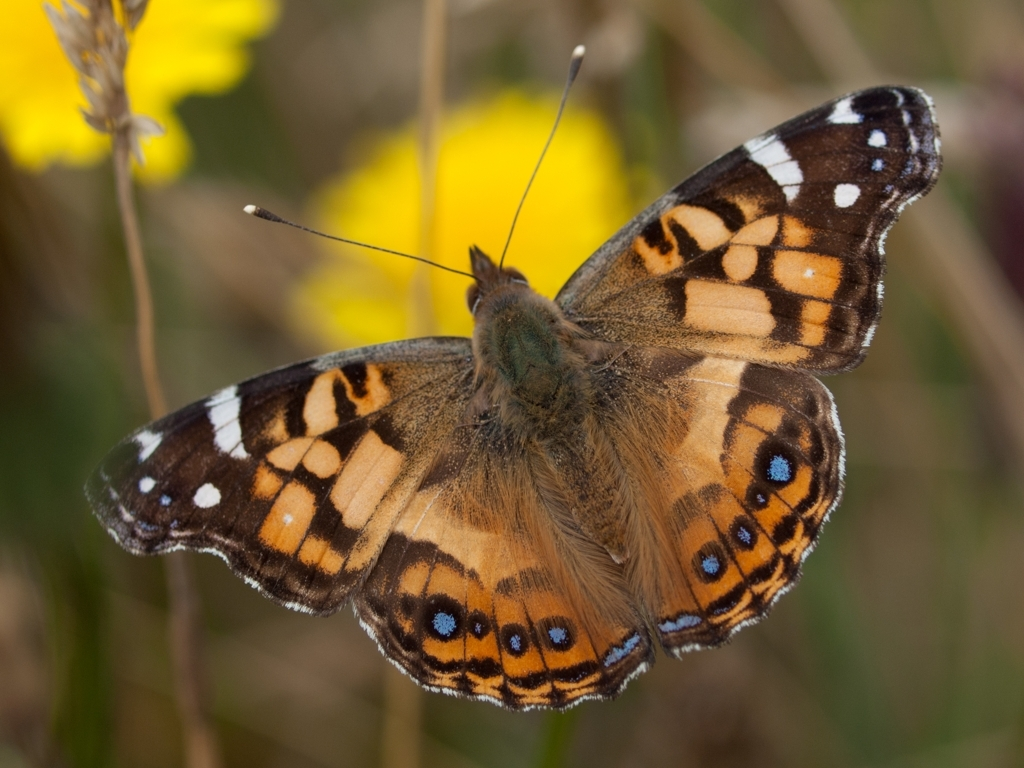How are the texture details of the captured butterfly subject? The butterfly depicted in the image showcases intricate texture details, highlighted by the fine scales on its wings which provide the appearance of a vivid mosaic. The interplay of orange, brown, white, and bits of blue near the lower edges of its hindwings creates a striking contrast against the blurry backdrop of yellow wildflowers and greenery. Such rich detailing not only contributes to the butterfly's aesthetic appeal but also serves functional purposes like camouflage and mate attraction. 